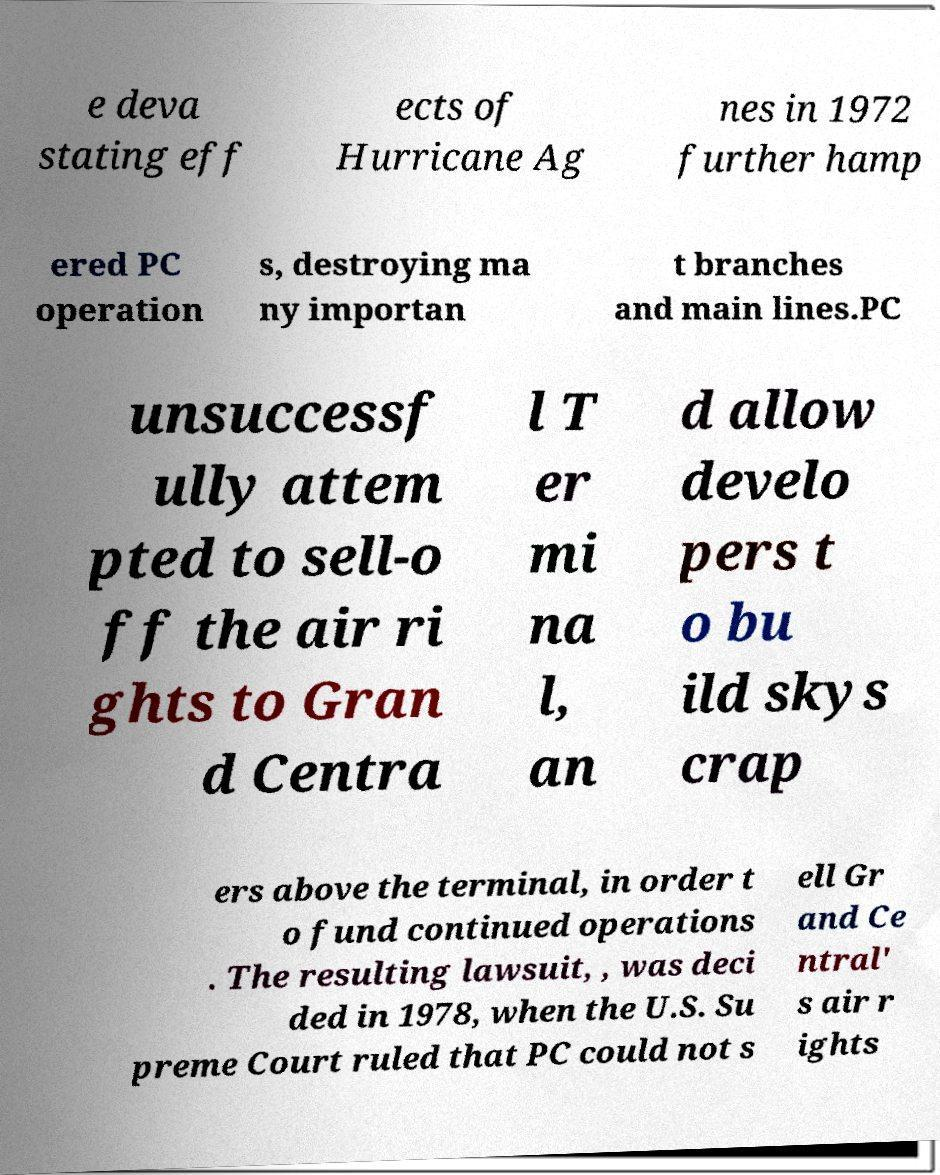Can you read and provide the text displayed in the image?This photo seems to have some interesting text. Can you extract and type it out for me? e deva stating eff ects of Hurricane Ag nes in 1972 further hamp ered PC operation s, destroying ma ny importan t branches and main lines.PC unsuccessf ully attem pted to sell-o ff the air ri ghts to Gran d Centra l T er mi na l, an d allow develo pers t o bu ild skys crap ers above the terminal, in order t o fund continued operations . The resulting lawsuit, , was deci ded in 1978, when the U.S. Su preme Court ruled that PC could not s ell Gr and Ce ntral' s air r ights 